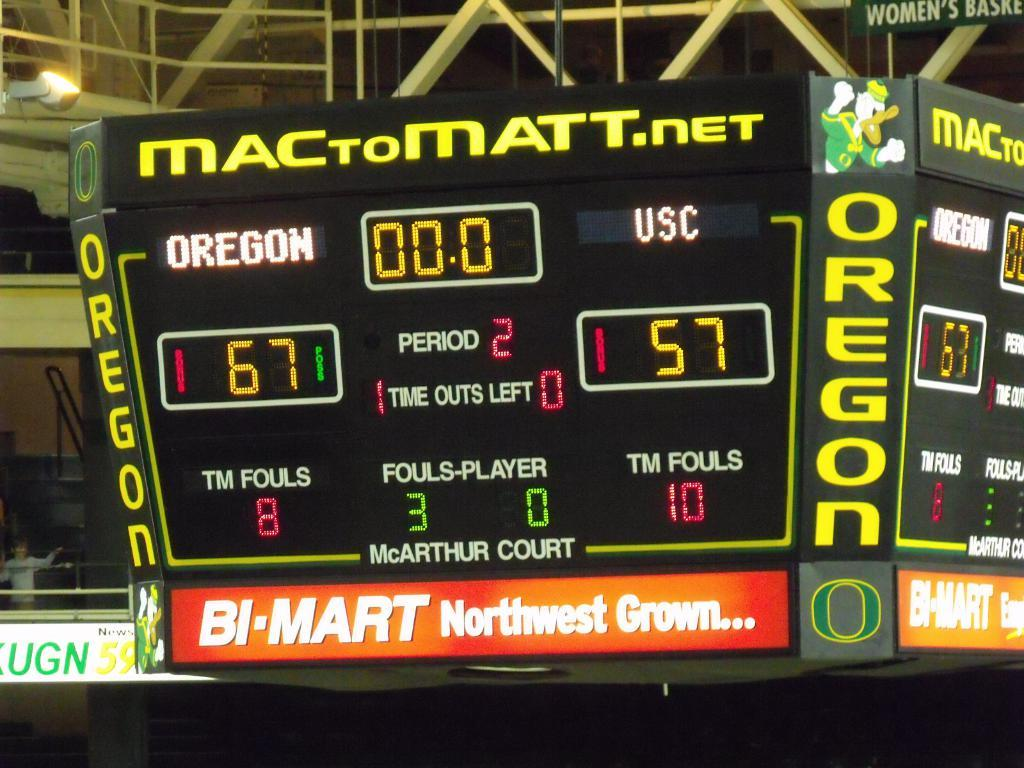<image>
Offer a succinct explanation of the picture presented. A basket ball scoreboard sponsored by Bi-mart shows Oregon are beating USC 67 to 57 